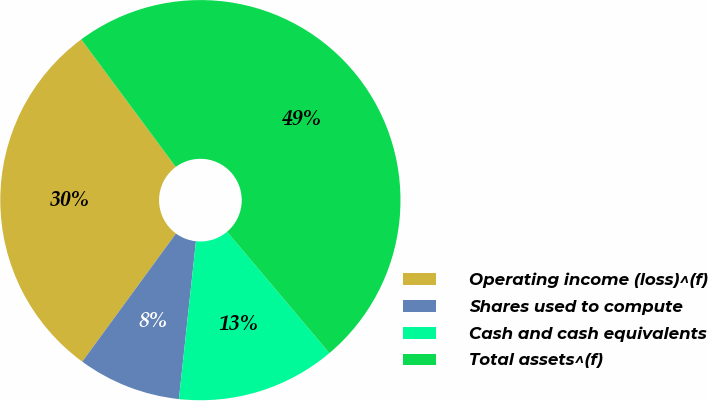Convert chart. <chart><loc_0><loc_0><loc_500><loc_500><pie_chart><fcel>Operating income (loss)^(f)<fcel>Shares used to compute<fcel>Cash and cash equivalents<fcel>Total assets^(f)<nl><fcel>29.8%<fcel>8.34%<fcel>12.86%<fcel>49.0%<nl></chart> 